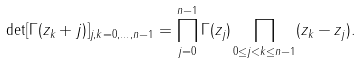<formula> <loc_0><loc_0><loc_500><loc_500>\det [ \Gamma ( z _ { k } + j ) ] _ { j , k = 0 , \dots , n - 1 } = \prod ^ { n - 1 } _ { j = 0 } \Gamma ( z _ { j } ) \prod _ { 0 \leq j < k \leq n - 1 } ( z _ { k } - z _ { j } ) .</formula> 